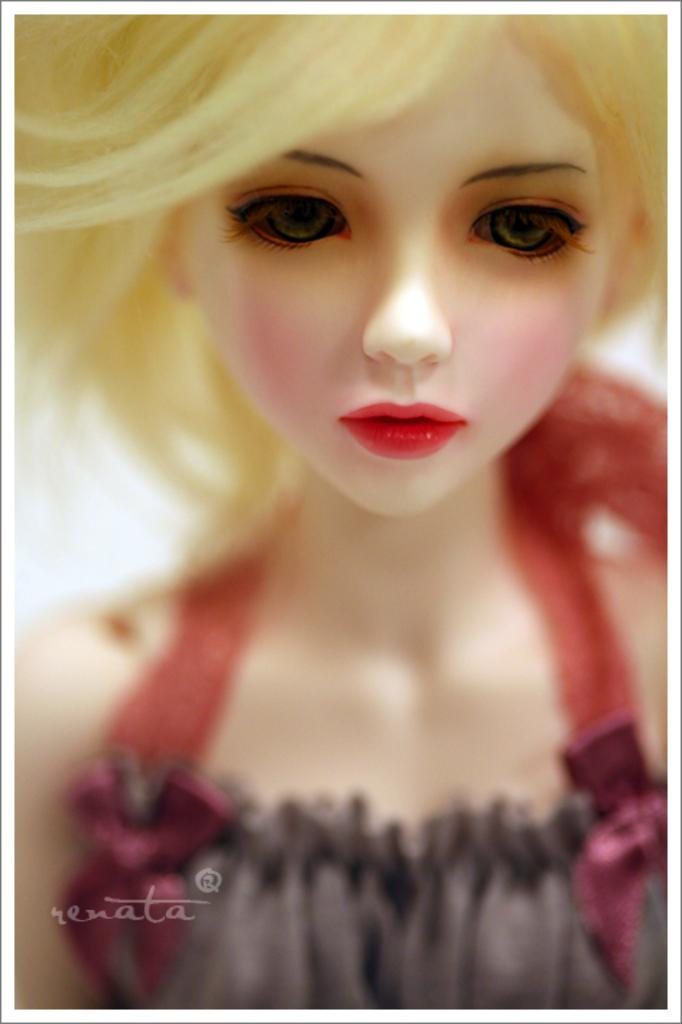What is present in the image? There is a doll in the image. Is there any text present in the image? Yes, there is text written at the bottom of the image. How many stitches are used to create the doll in the image? There is no information provided about the number of stitches used to create the doll in the image. 